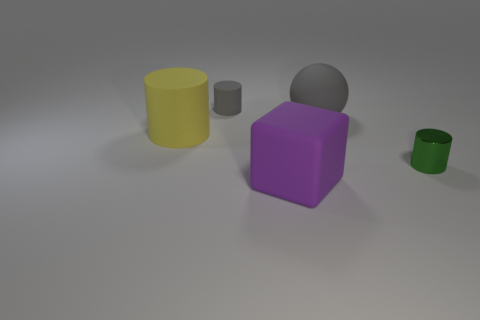Subtract all matte cylinders. How many cylinders are left? 1 Subtract all balls. How many objects are left? 4 Add 2 small brown cylinders. How many objects exist? 7 Subtract all cyan matte cylinders. Subtract all small gray cylinders. How many objects are left? 4 Add 3 small matte objects. How many small matte objects are left? 4 Add 5 tiny yellow metal objects. How many tiny yellow metal objects exist? 5 Subtract 0 brown spheres. How many objects are left? 5 